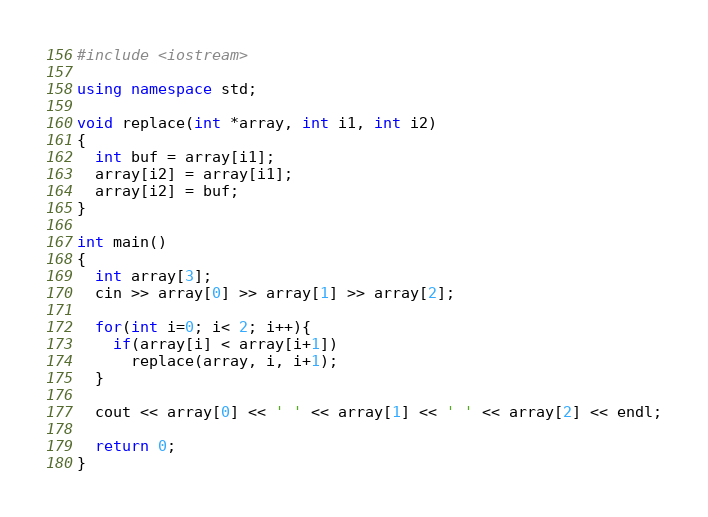<code> <loc_0><loc_0><loc_500><loc_500><_C++_>#include <iostream>

using namespace std;

void replace(int *array, int i1, int i2)
{
  int buf = array[i1];
  array[i2] = array[i1];
  array[i2] = buf;
}

int main()
{
  int array[3];
  cin >> array[0] >> array[1] >> array[2];

  for(int i=0; i< 2; i++){
    if(array[i] < array[i+1])
      replace(array, i, i+1);
  }

  cout << array[0] << ' ' << array[1] << ' ' << array[2] << endl;

  return 0;
}</code> 